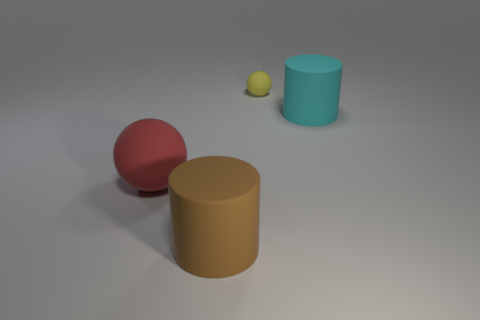Are there any tiny rubber balls of the same color as the small thing?
Provide a short and direct response. No. There is a cyan rubber cylinder; is its size the same as the cylinder that is in front of the big red sphere?
Give a very brief answer. Yes. There is a matte ball that is in front of the rubber object on the right side of the tiny rubber ball; how many large brown matte cylinders are right of it?
Your answer should be compact. 1. What number of small yellow rubber balls are on the left side of the yellow rubber thing?
Ensure brevity in your answer.  0. There is a big object that is right of the ball that is behind the large cyan cylinder; what color is it?
Ensure brevity in your answer.  Cyan. What number of other things are the same material as the yellow sphere?
Offer a terse response. 3. Is the number of small things that are in front of the large ball the same as the number of yellow spheres?
Give a very brief answer. No. What material is the big cylinder that is in front of the cylinder behind the rubber cylinder in front of the large red object?
Give a very brief answer. Rubber. There is a big thing on the right side of the brown object; what is its color?
Keep it short and to the point. Cyan. Is there anything else that is the same shape as the tiny yellow rubber thing?
Your response must be concise. Yes. 